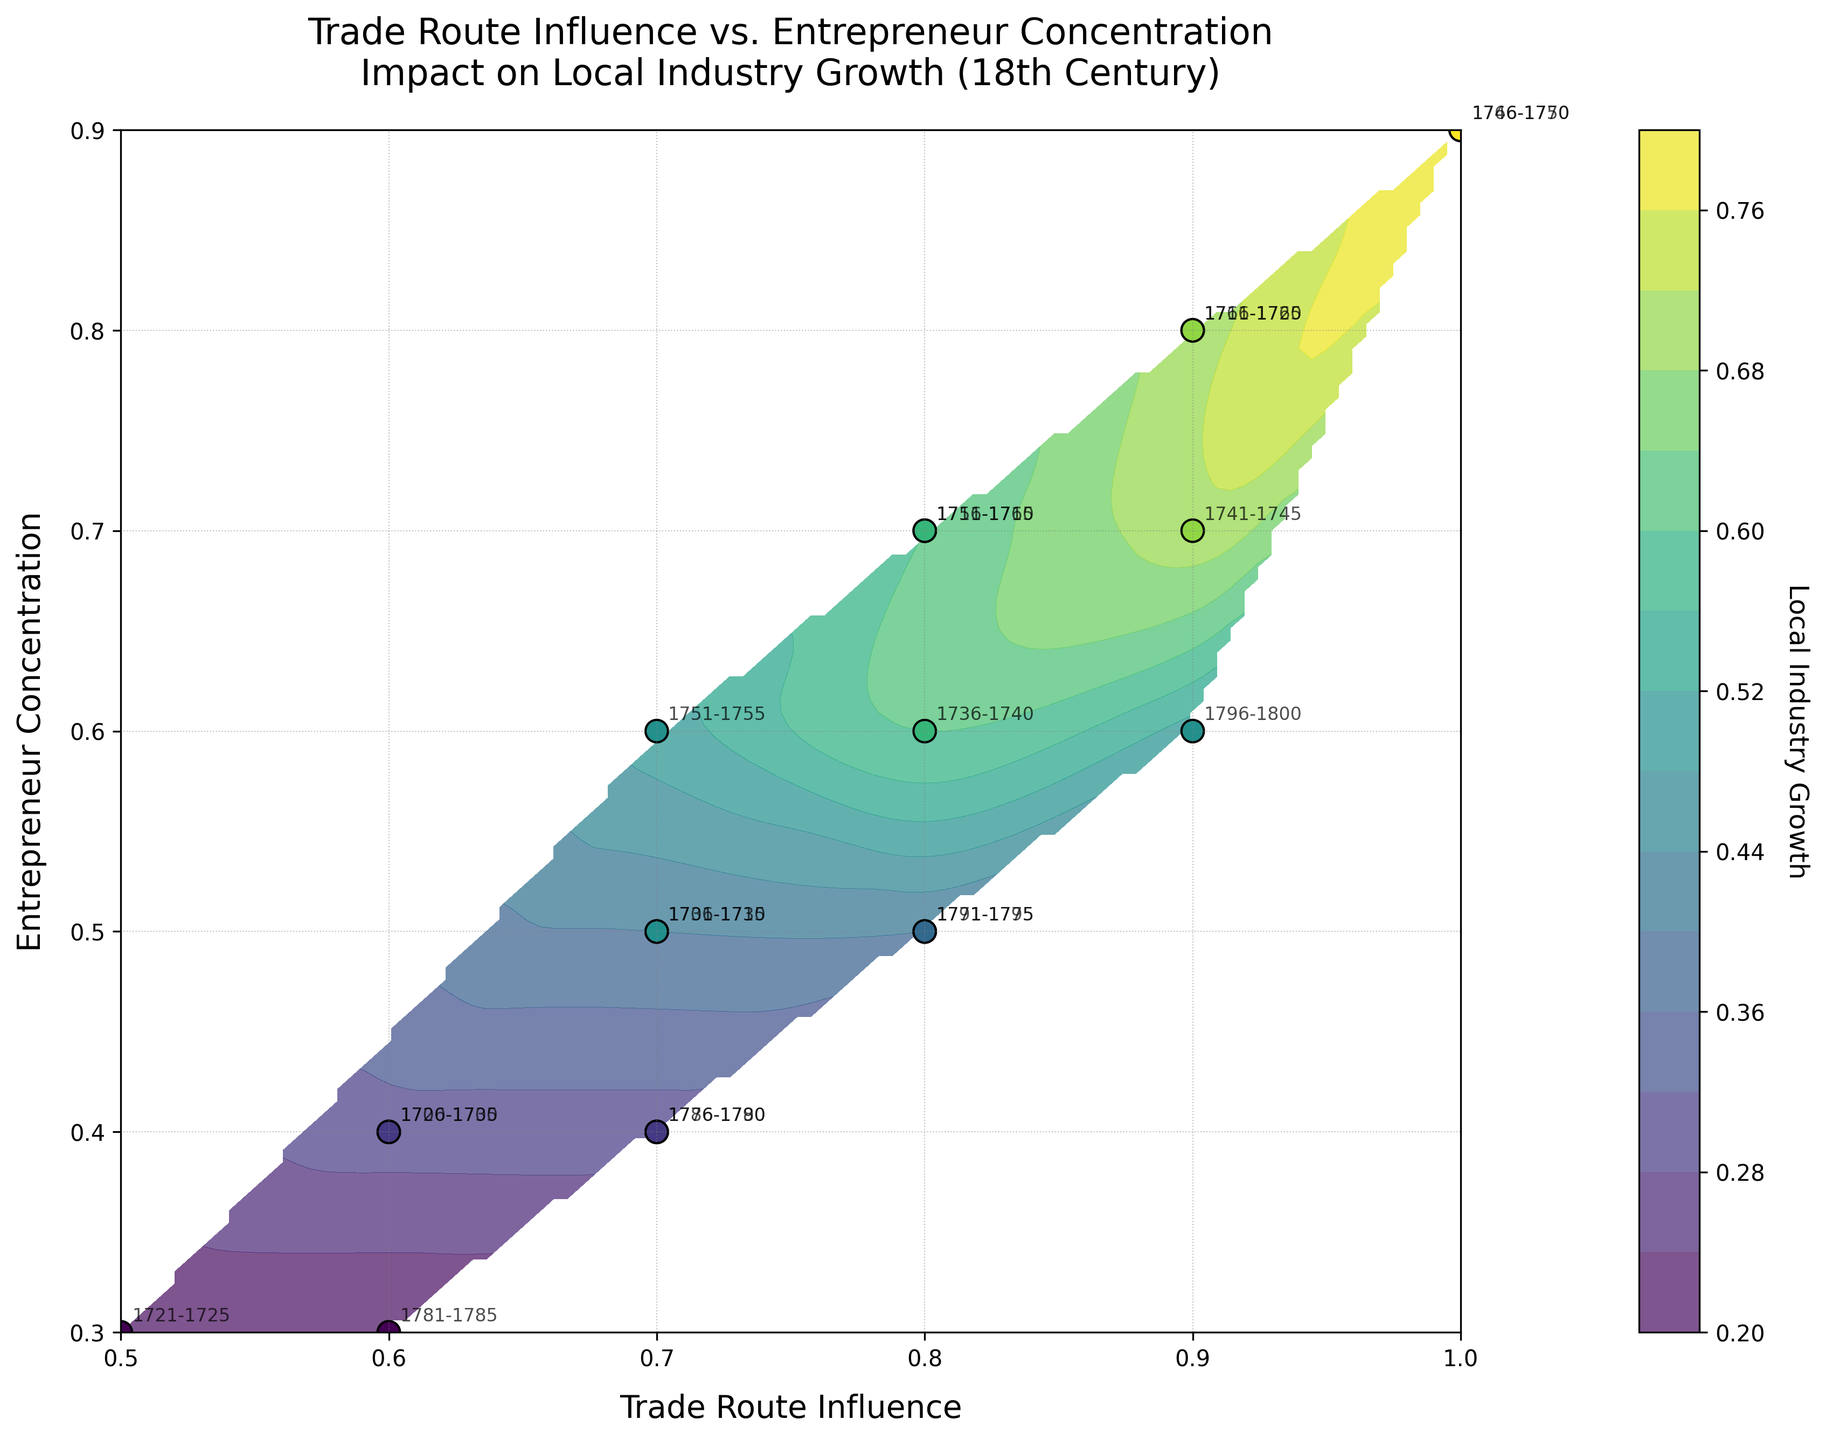What is the title of the plot? The title is displayed at the top of the plot. It summarizes the plot's main idea about the relationship between trade route influence, entrepreneur concentration, and local industry growth in the 18th century.
Answer: Trade Route Influence vs. Entrepreneur Concentration Impact on Local Industry Growth (18th Century) What are the labels on the axes? The axes labels provide context for what the x and y axes represent. The x-axis label represents 'Trade Route Influence' and the y-axis label represents 'Entrepreneur Concentration'.
Answer: Trade Route Influence (x), Entrepreneur Concentration (y) How many data points are represented in the plot? Each scatter point in the plot corresponds to one data point. By counting them directly, we get a total of 20 data points.
Answer: 20 What does the color of the contour plot represent? The color of the contour plot represents the 'Local Industry Growth,' as indicated by the color bar on the side. Darker colors typically represent higher growth values, and lighter colors represent lower growth.
Answer: Local Industry Growth Which time period shows the highest local industry growth? Locate the point with the highest 'Local Industry Growth' color value and identify the labeled time period. The highest value points are typically around 1.0 Trade Route Influence and 0.9 Entrepreneur Concentration, indicating the 1746-1750 and 1766-1770 periods.
Answer: 1746-1750, 1766-1770 Between 1700-1705 and 1786-1790, which period had higher entrepreneur concentration? Identify the points for the two periods and compare their y-axis values. 1700-1705 has an entrepreneur concentration of 0.4, whereas 1786-1790 has an entrepreneur concentration of 0.4. Since they are equal, they have the same concentration.
Answer: Equal How does the local industry growth change as trade route influence increases from 0.5 to 1.0? Observe the gradient of the contour colors from left (0.5 Trade Route Influence) to right (1.0 Trade Route Influence). As trade route influence increases, the contour colors generally become darker, indicating higher local industry growth.
Answer: Increases Is there a direct relationship between trade route influence and local industry growth? The contour lines' gradient and the scatter points' color distribution primarily slope upwards from left to right, signifying that higher trade route influence tends to correspond with higher local industry growth.
Answer: Yes For the time period 1731-1735, what is the approximate local industry growth value? Locate the point labeled 1731-1735 and note its color and position on the contour plot. The color is similar to the 0.5 growth region on the color bar.
Answer: Approximately 0.5 Do periods with higher trade route influence generally have higher entrepreneur concentration? By examining the scatter points on both axes, it is noticeable that higher trade route influence values (right side) are often accompanied by higher entrepreneur concentrations (upper regions).
Answer: Generally, yes 